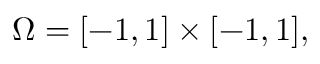<formula> <loc_0><loc_0><loc_500><loc_500>\Omega = [ - 1 , 1 ] \times [ - 1 , 1 ] ,</formula> 